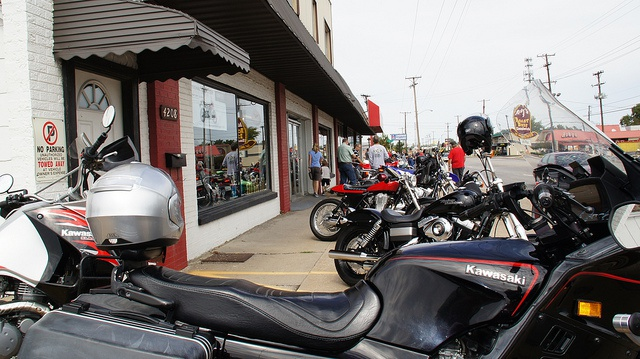Describe the objects in this image and their specific colors. I can see motorcycle in salmon, black, gray, and darkgray tones, motorcycle in salmon, black, white, gray, and darkgray tones, motorcycle in salmon, black, gray, darkgray, and lightgray tones, motorcycle in salmon, black, gray, darkgray, and lightgray tones, and car in salmon, darkgray, and gray tones in this image. 